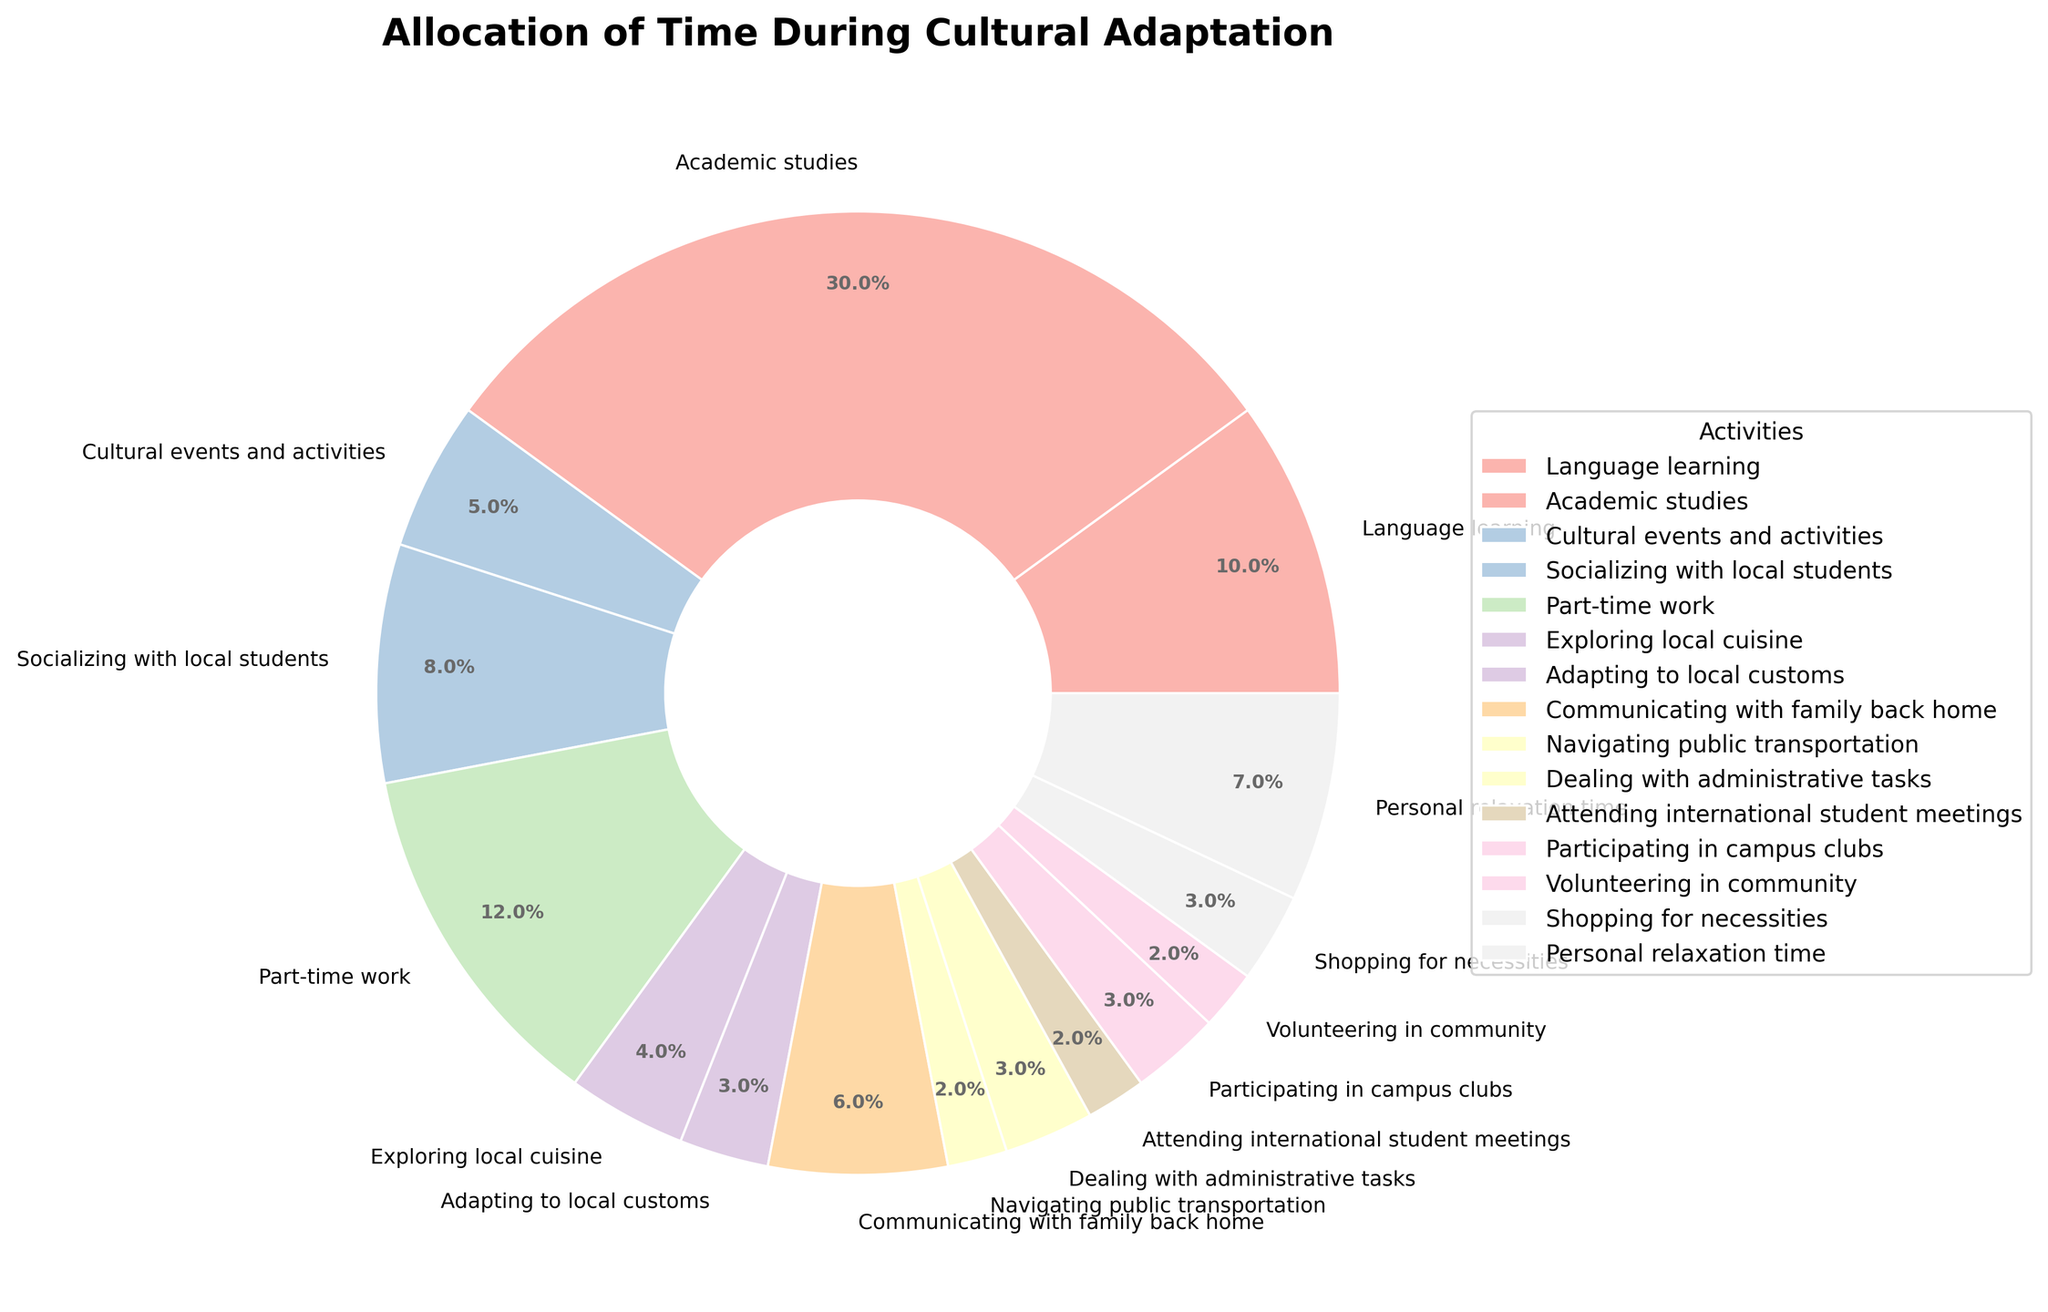What's the activity that takes up the most weekly hours? The pie chart shows the allocation of time spent on various activities. The largest section of the pie chart represents the activity with the most weekly hours. In this case, 'Academic studies' occupies the largest portion.
Answer: Academic studies What percentage of time is spent on Language learning and Socializing with local students combined? To find the combined percentage, add the percentages for 'Language learning' and 'Socializing with local students' from the pie chart. 'Language learning' is 13.9% and 'Socializing with local students' is 11.1%. Adding these gives 13.9% + 11.1% = 25.0%.
Answer: 25.0% Which activity takes up fewer hours than 'Language learning' but more hours than 'Cultural events and activities'? Look for the activity that has fewer hours than the 10 hours spent on 'Language learning' and more than the 5 hours spent on 'Cultural events and activities'. 'Socializing with local students' fits this criterion with 8 hours.
Answer: Socializing with local students How many hours per week are spent on Communicating with family back home and Shopping for necessities combined? 'Communicating with family back home' takes 6 hours and 'Shopping for necessities' takes 3 hours. Adding these gives 6 + 3 = 9 hours per week.
Answer: 9 hours What fraction of time is dedicated to Personal relaxation time? Personal relaxation time takes up 7 hours per week out of a total of 90 hours (sum of all activities). The fraction is 7/90. Simplifying this fraction gives approximately 7.78%.
Answer: 7.8% Compare the time spent on Part-time work and Exploring local cuisine. Which one takes up more time? To compare, look at each section in the pie chart. 'Part-time work' has 12 hours while 'Exploring local cuisine' has 4 hours. Part-time work takes up more time.
Answer: Part-time work Which two activities combined take up exactly 10 hours per week? From the pie chart, activities that add up to 10 hours are 'Exploring local cuisine' (4 hours) and 'Shopping for necessities' (3 hours) plus 'Navigating public transportation' (2 hours) and 'Attending international student meetings' (2 hours). Therefore, the combinations are 'Exploring local cuisine' and 'Shopping for necessities and Navigating public transportation and Attending international student meetings' (2+2+2).
Answer: Exploring local cuisine and Shopping for necessities; Navigating public transportation and Attending international student meetings What is the percentage of time spent on Dealing with administrative tasks and Adapting to local customs? 'Dealing with administrative tasks' takes 3 hours, and 'Adapting to local customs' takes 3 hours, making a total of 6 hours. The percentage is (6/90) * 100% = 6.7%.
Answer: 6.7% Which activity occupies the smallest portion of the pie chart? Look for the smallest section in the pie chart. The smallest section represents 'Navigating public transportation' and 'Volunteering in community,' each taking up 2 hours. Both occupy equally tiny portions.
Answer: Navigating public transportation and Volunteering in community 